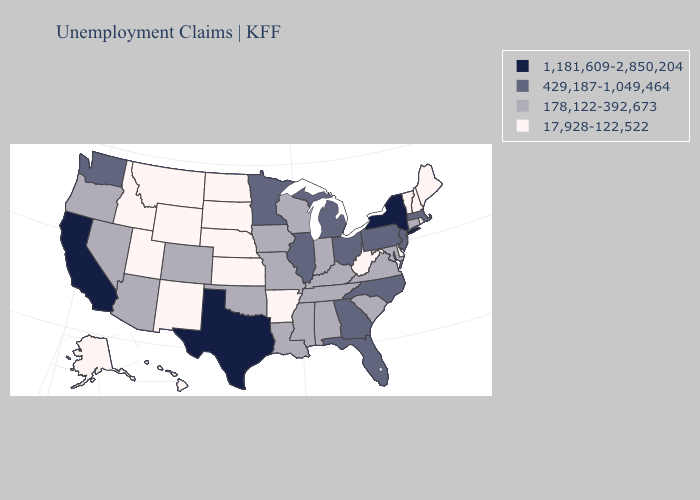What is the highest value in the MidWest ?
Keep it brief. 429,187-1,049,464. Among the states that border Tennessee , does Missouri have the highest value?
Keep it brief. No. Does Pennsylvania have a lower value than New York?
Write a very short answer. Yes. Which states have the lowest value in the USA?
Be succinct. Alaska, Arkansas, Delaware, Hawaii, Idaho, Kansas, Maine, Montana, Nebraska, New Hampshire, New Mexico, North Dakota, Rhode Island, South Dakota, Utah, Vermont, West Virginia, Wyoming. What is the value of Vermont?
Short answer required. 17,928-122,522. Which states have the lowest value in the USA?
Be succinct. Alaska, Arkansas, Delaware, Hawaii, Idaho, Kansas, Maine, Montana, Nebraska, New Hampshire, New Mexico, North Dakota, Rhode Island, South Dakota, Utah, Vermont, West Virginia, Wyoming. Which states have the highest value in the USA?
Give a very brief answer. California, New York, Texas. Does Nevada have the lowest value in the USA?
Be succinct. No. Does Georgia have the lowest value in the USA?
Keep it brief. No. Name the states that have a value in the range 1,181,609-2,850,204?
Be succinct. California, New York, Texas. What is the highest value in the Northeast ?
Short answer required. 1,181,609-2,850,204. Which states have the lowest value in the USA?
Concise answer only. Alaska, Arkansas, Delaware, Hawaii, Idaho, Kansas, Maine, Montana, Nebraska, New Hampshire, New Mexico, North Dakota, Rhode Island, South Dakota, Utah, Vermont, West Virginia, Wyoming. Name the states that have a value in the range 178,122-392,673?
Keep it brief. Alabama, Arizona, Colorado, Connecticut, Indiana, Iowa, Kentucky, Louisiana, Maryland, Mississippi, Missouri, Nevada, Oklahoma, Oregon, South Carolina, Tennessee, Virginia, Wisconsin. What is the value of Nebraska?
Give a very brief answer. 17,928-122,522. What is the value of Nevada?
Short answer required. 178,122-392,673. 